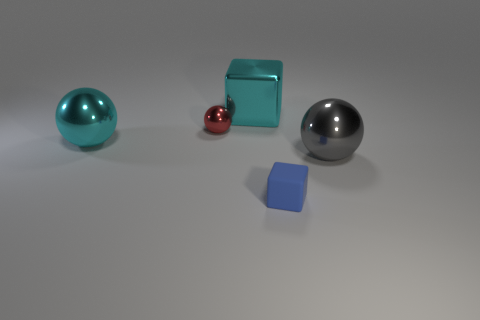There is a blue block that is in front of the big shiny thing behind the small shiny sphere that is behind the blue matte block; what is it made of?
Your response must be concise. Rubber. Are there any other things of the same color as the metal cube?
Offer a terse response. Yes. Is the color of the block that is left of the blue object the same as the large ball to the left of the large cyan block?
Ensure brevity in your answer.  Yes. What is the shape of the metal object that is the same color as the large shiny cube?
Provide a succinct answer. Sphere. Is the number of purple shiny blocks greater than the number of big cyan objects?
Offer a very short reply. No. The small thing that is to the right of the large cyan shiny cube has what shape?
Provide a short and direct response. Cube. What number of large green shiny things have the same shape as the red metallic thing?
Offer a terse response. 0. What is the size of the object that is in front of the big metal thing right of the blue matte block?
Provide a short and direct response. Small. What number of purple things are either big things or small balls?
Ensure brevity in your answer.  0. Are there fewer cyan shiny balls that are behind the cyan cube than small blue things that are in front of the large gray metal thing?
Provide a succinct answer. Yes. 